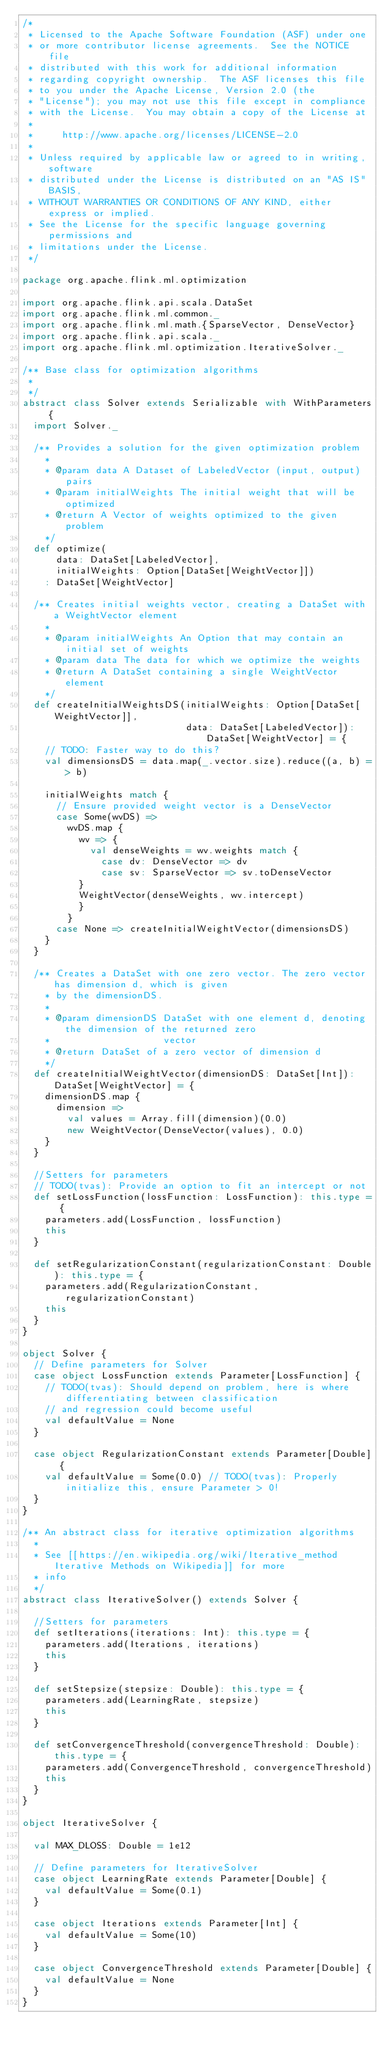Convert code to text. <code><loc_0><loc_0><loc_500><loc_500><_Scala_>/*
 * Licensed to the Apache Software Foundation (ASF) under one
 * or more contributor license agreements.  See the NOTICE file
 * distributed with this work for additional information
 * regarding copyright ownership.  The ASF licenses this file
 * to you under the Apache License, Version 2.0 (the
 * "License"); you may not use this file except in compliance
 * with the License.  You may obtain a copy of the License at
 *
 *     http://www.apache.org/licenses/LICENSE-2.0
 *
 * Unless required by applicable law or agreed to in writing, software
 * distributed under the License is distributed on an "AS IS" BASIS,
 * WITHOUT WARRANTIES OR CONDITIONS OF ANY KIND, either express or implied.
 * See the License for the specific language governing permissions and
 * limitations under the License.
 */

package org.apache.flink.ml.optimization

import org.apache.flink.api.scala.DataSet
import org.apache.flink.ml.common._
import org.apache.flink.ml.math.{SparseVector, DenseVector}
import org.apache.flink.api.scala._
import org.apache.flink.ml.optimization.IterativeSolver._

/** Base class for optimization algorithms
 *
 */
abstract class Solver extends Serializable with WithParameters {
  import Solver._

  /** Provides a solution for the given optimization problem
    *
    * @param data A Dataset of LabeledVector (input, output) pairs
    * @param initialWeights The initial weight that will be optimized
    * @return A Vector of weights optimized to the given problem
    */
  def optimize(
      data: DataSet[LabeledVector],
      initialWeights: Option[DataSet[WeightVector]])
    : DataSet[WeightVector]

  /** Creates initial weights vector, creating a DataSet with a WeightVector element
    *
    * @param initialWeights An Option that may contain an initial set of weights
    * @param data The data for which we optimize the weights
    * @return A DataSet containing a single WeightVector element
    */
  def createInitialWeightsDS(initialWeights: Option[DataSet[WeightVector]],
                             data: DataSet[LabeledVector]): DataSet[WeightVector] = {
    // TODO: Faster way to do this?
    val dimensionsDS = data.map(_.vector.size).reduce((a, b) => b)

    initialWeights match {
      // Ensure provided weight vector is a DenseVector
      case Some(wvDS) =>
        wvDS.map {
          wv => {
            val denseWeights = wv.weights match {
              case dv: DenseVector => dv
              case sv: SparseVector => sv.toDenseVector
          }
          WeightVector(denseWeights, wv.intercept)
          }
        }
      case None => createInitialWeightVector(dimensionsDS)
    }
  }

  /** Creates a DataSet with one zero vector. The zero vector has dimension d, which is given
    * by the dimensionDS.
    *
    * @param dimensionDS DataSet with one element d, denoting the dimension of the returned zero
    *                    vector
    * @return DataSet of a zero vector of dimension d
    */
  def createInitialWeightVector(dimensionDS: DataSet[Int]): DataSet[WeightVector] = {
    dimensionDS.map {
      dimension =>
        val values = Array.fill(dimension)(0.0)
        new WeightVector(DenseVector(values), 0.0)
    }
  }

  //Setters for parameters
  // TODO(tvas): Provide an option to fit an intercept or not
  def setLossFunction(lossFunction: LossFunction): this.type = {
    parameters.add(LossFunction, lossFunction)
    this
  }

  def setRegularizationConstant(regularizationConstant: Double): this.type = {
    parameters.add(RegularizationConstant, regularizationConstant)
    this
  }
}

object Solver {
  // Define parameters for Solver
  case object LossFunction extends Parameter[LossFunction] {
    // TODO(tvas): Should depend on problem, here is where differentiating between classification
    // and regression could become useful
    val defaultValue = None
  }

  case object RegularizationConstant extends Parameter[Double] {
    val defaultValue = Some(0.0) // TODO(tvas): Properly initialize this, ensure Parameter > 0!
  }
}

/** An abstract class for iterative optimization algorithms
  *
  * See [[https://en.wikipedia.org/wiki/Iterative_method Iterative Methods on Wikipedia]] for more
  * info
  */
abstract class IterativeSolver() extends Solver {

  //Setters for parameters
  def setIterations(iterations: Int): this.type = {
    parameters.add(Iterations, iterations)
    this
  }

  def setStepsize(stepsize: Double): this.type = {
    parameters.add(LearningRate, stepsize)
    this
  }

  def setConvergenceThreshold(convergenceThreshold: Double): this.type = {
    parameters.add(ConvergenceThreshold, convergenceThreshold)
    this
  }
}

object IterativeSolver {

  val MAX_DLOSS: Double = 1e12

  // Define parameters for IterativeSolver
  case object LearningRate extends Parameter[Double] {
    val defaultValue = Some(0.1)
  }

  case object Iterations extends Parameter[Int] {
    val defaultValue = Some(10)
  }

  case object ConvergenceThreshold extends Parameter[Double] {
    val defaultValue = None
  }
}
</code> 